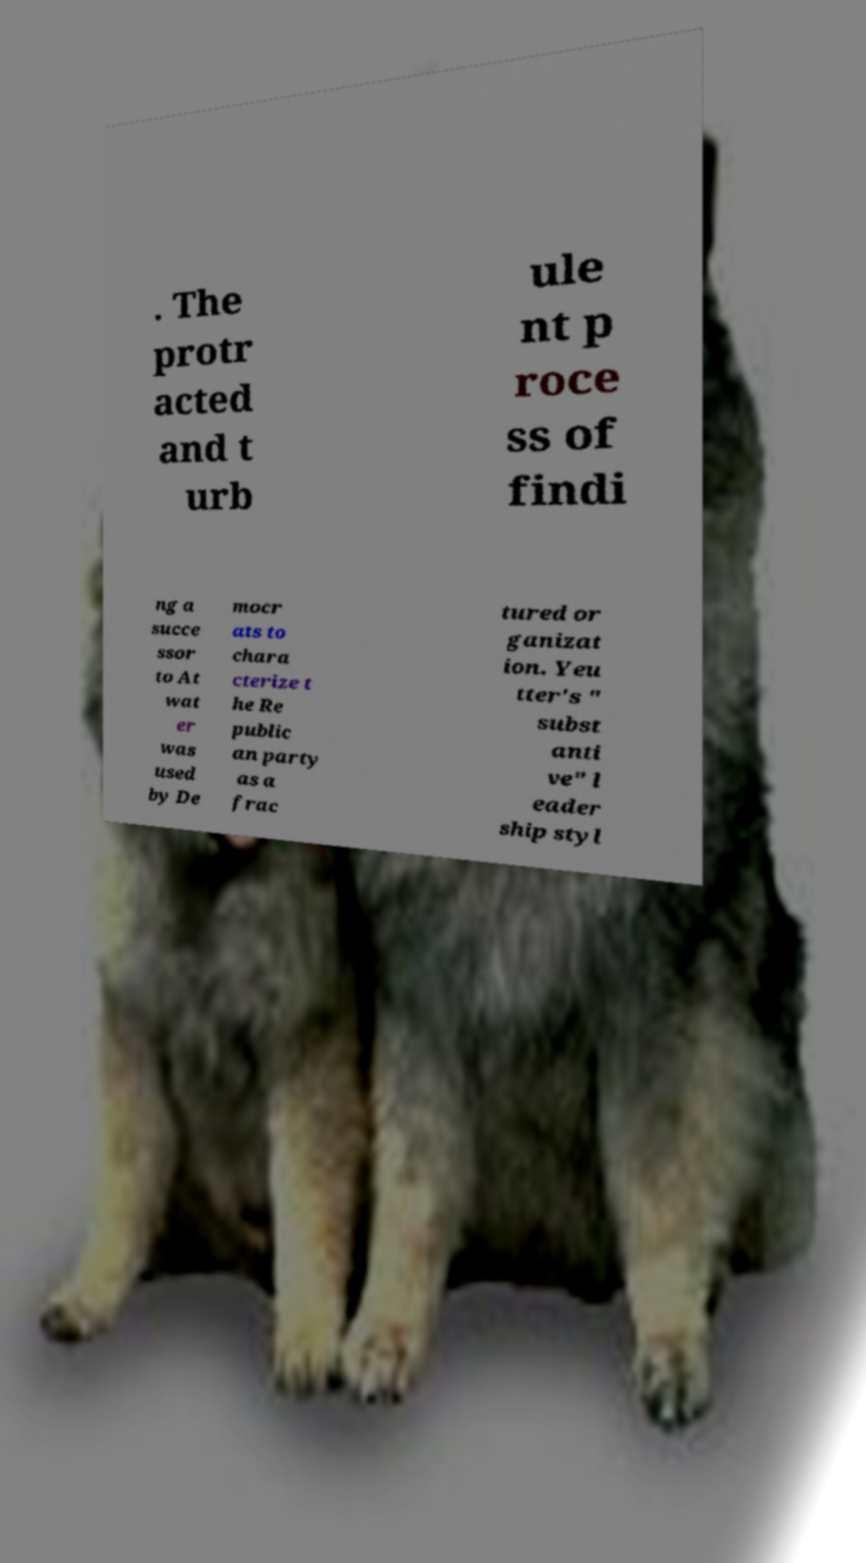For documentation purposes, I need the text within this image transcribed. Could you provide that? . The protr acted and t urb ule nt p roce ss of findi ng a succe ssor to At wat er was used by De mocr ats to chara cterize t he Re public an party as a frac tured or ganizat ion. Yeu tter's " subst anti ve" l eader ship styl 